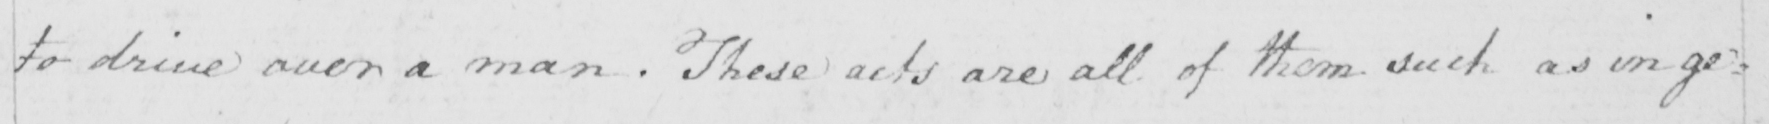Transcribe the text shown in this historical manuscript line. to drive over a man . These acts are all of them such as in ge= 